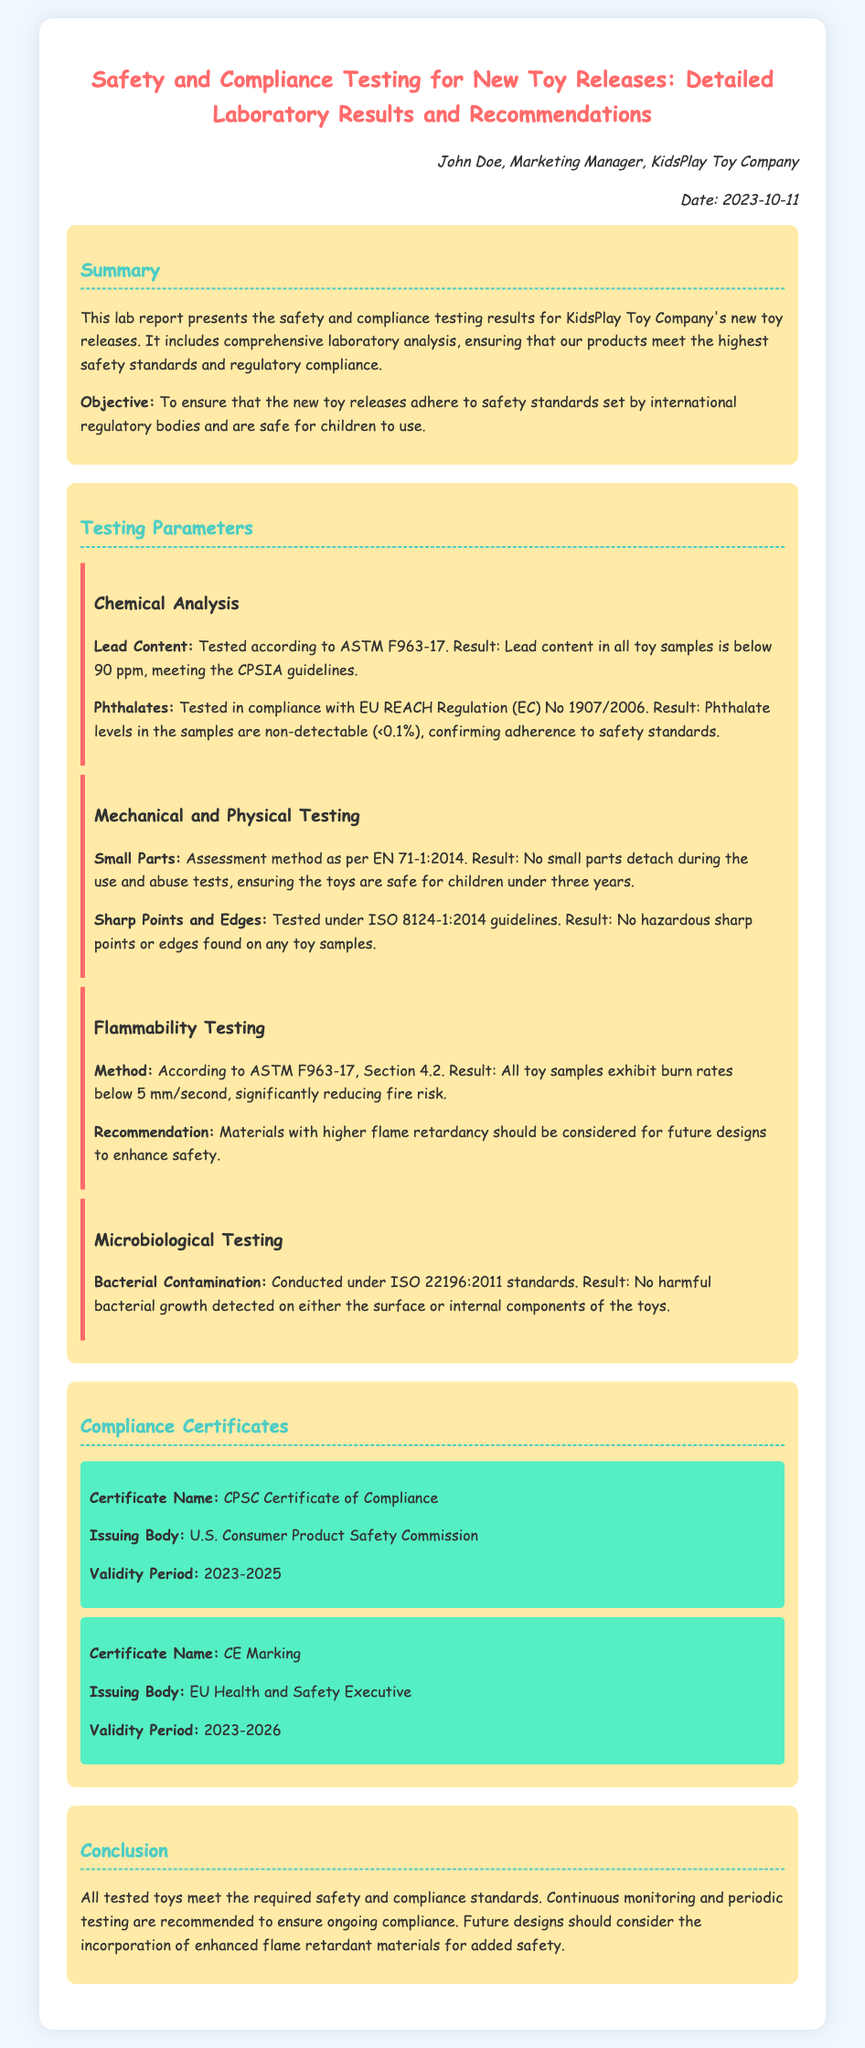what is the title of the report? The title provided at the top of the document indicates the focus of the report on safety and compliance testing.
Answer: Safety and Compliance Testing for New Toy Releases: Detailed Laboratory Results and Recommendations who is the author of the report? The author of the report is mentioned in the document and is responsible for its content.
Answer: John Doe what is the lead content result in the toy samples? The document specifies the lead content result related to the testing according to the respective standards.
Answer: below 90 ppm what year is the certificate of compliance valid until? The validity period of the CPSC Certificate of Compliance is specified in the document.
Answer: 2025 how was bacterial contamination tested? The method used to conduct the bacterial contamination testing is outlined in the testing parameters section.
Answer: ISO 22196:2011 what should be considered for future toy designs? The document concludes with recommendations for future considerations to enhance safety.
Answer: Enhanced flame retardant materials what does the flammability testing method comply with? The method for flammability testing is explicitly mentioned in the findings of the document.
Answer: ASTM F963-17 how many compliance certificates are listed? The document indicates the number of compliance certificates that are mentioned in the compliance section.
Answer: 2 what was the result of the sharp points and edges testing? The findings from the testing of sharp points and edges are included in the mechanical and physical testing section of the report.
Answer: No hazardous sharp points or edges found 